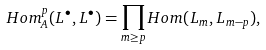Convert formula to latex. <formula><loc_0><loc_0><loc_500><loc_500>H o m _ { A } ^ { p } ( L ^ { \bullet } , L ^ { \bullet } ) & = \prod _ { m \geq p } H o m ( L _ { m } , L _ { m - p } ) ,</formula> 